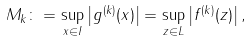Convert formula to latex. <formula><loc_0><loc_0><loc_500><loc_500>M _ { k } \colon = \underset { x \in I } { \sup } \left | g ^ { ( k ) } ( x ) \right | = \underset { z \in L } { \sup } \left | f ^ { ( k ) } ( z ) \right | ,</formula> 